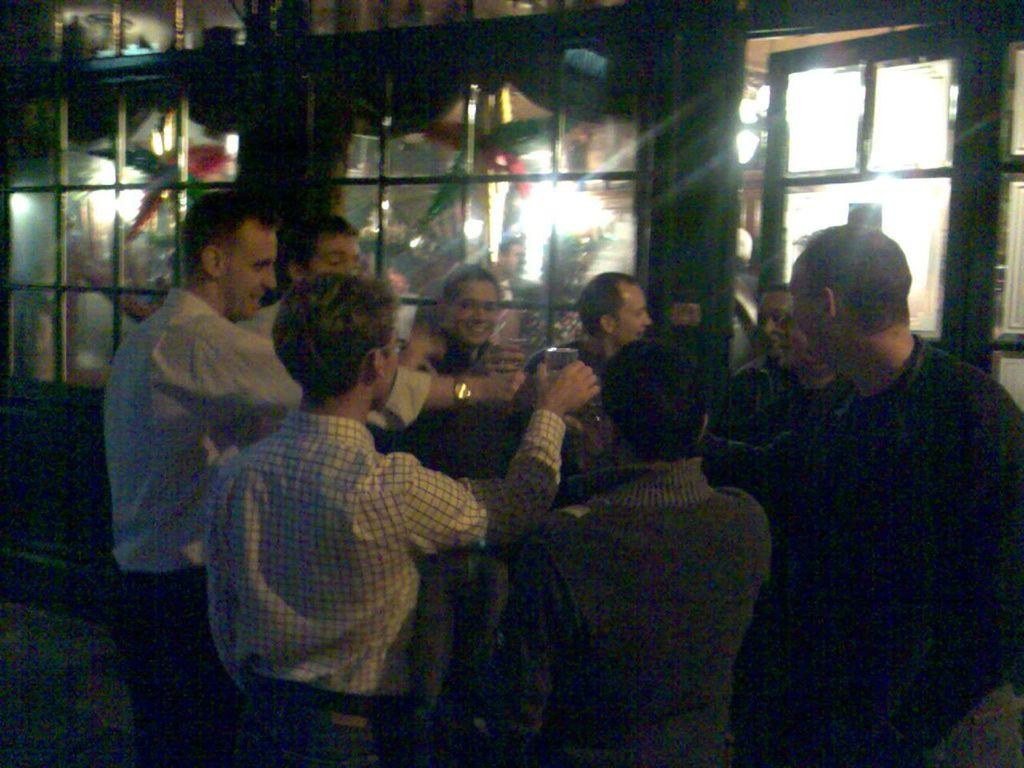What are the people in the image doing? The people in the image are standing and holding glasses. What can be seen behind the people in the image? There is a glass wall visible in the image. Are there any rabbits visible in the image? No, there are no rabbits present in the image. Is there any quicksand visible in the image? No, there is no quicksand present in the image. 